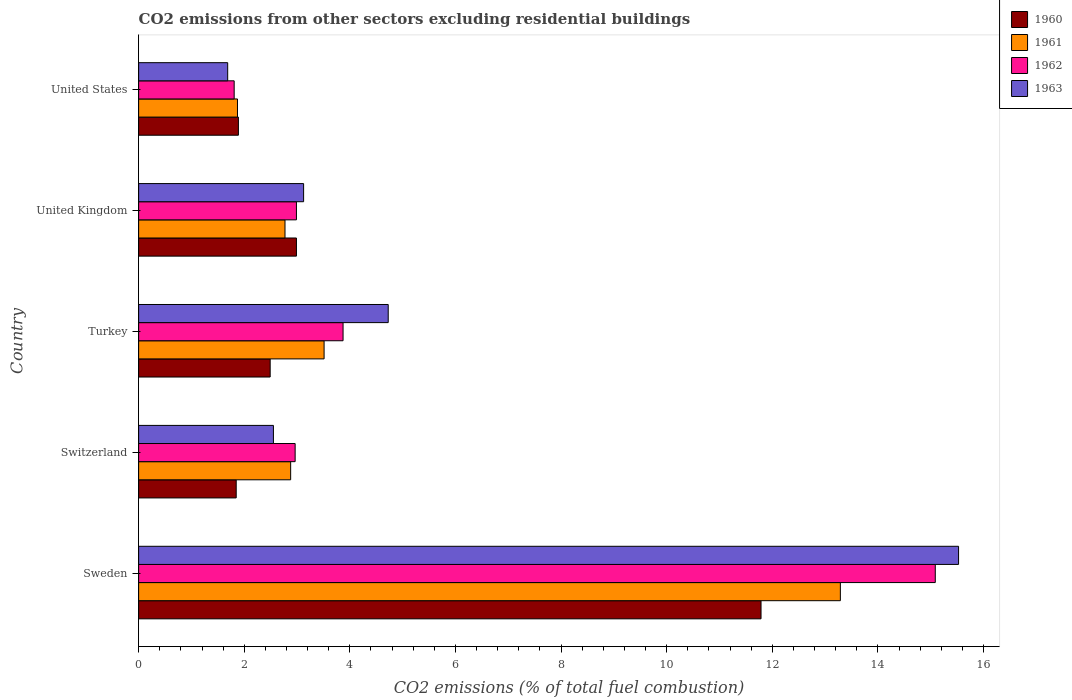Are the number of bars on each tick of the Y-axis equal?
Provide a short and direct response. Yes. What is the label of the 2nd group of bars from the top?
Offer a very short reply. United Kingdom. In how many cases, is the number of bars for a given country not equal to the number of legend labels?
Your response must be concise. 0. What is the total CO2 emitted in 1963 in Turkey?
Give a very brief answer. 4.73. Across all countries, what is the maximum total CO2 emitted in 1963?
Provide a short and direct response. 15.53. Across all countries, what is the minimum total CO2 emitted in 1962?
Keep it short and to the point. 1.81. In which country was the total CO2 emitted in 1961 minimum?
Offer a very short reply. United States. What is the total total CO2 emitted in 1961 in the graph?
Your answer should be compact. 24.32. What is the difference between the total CO2 emitted in 1960 in Turkey and that in United Kingdom?
Offer a very short reply. -0.5. What is the difference between the total CO2 emitted in 1963 in Switzerland and the total CO2 emitted in 1962 in United Kingdom?
Offer a terse response. -0.44. What is the average total CO2 emitted in 1963 per country?
Offer a terse response. 5.52. What is the difference between the total CO2 emitted in 1963 and total CO2 emitted in 1960 in United Kingdom?
Keep it short and to the point. 0.14. In how many countries, is the total CO2 emitted in 1961 greater than 0.8 ?
Your answer should be compact. 5. What is the ratio of the total CO2 emitted in 1962 in Switzerland to that in United States?
Make the answer very short. 1.64. Is the difference between the total CO2 emitted in 1963 in Sweden and Turkey greater than the difference between the total CO2 emitted in 1960 in Sweden and Turkey?
Make the answer very short. Yes. What is the difference between the highest and the second highest total CO2 emitted in 1962?
Provide a succinct answer. 11.21. What is the difference between the highest and the lowest total CO2 emitted in 1963?
Provide a short and direct response. 13.84. Is it the case that in every country, the sum of the total CO2 emitted in 1960 and total CO2 emitted in 1961 is greater than the sum of total CO2 emitted in 1962 and total CO2 emitted in 1963?
Offer a terse response. No. What does the 3rd bar from the bottom in United Kingdom represents?
Offer a terse response. 1962. What is the difference between two consecutive major ticks on the X-axis?
Give a very brief answer. 2. Are the values on the major ticks of X-axis written in scientific E-notation?
Offer a very short reply. No. Does the graph contain any zero values?
Your answer should be very brief. No. Does the graph contain grids?
Give a very brief answer. No. How many legend labels are there?
Your response must be concise. 4. What is the title of the graph?
Your response must be concise. CO2 emissions from other sectors excluding residential buildings. What is the label or title of the X-axis?
Ensure brevity in your answer.  CO2 emissions (% of total fuel combustion). What is the label or title of the Y-axis?
Your answer should be very brief. Country. What is the CO2 emissions (% of total fuel combustion) of 1960 in Sweden?
Offer a very short reply. 11.79. What is the CO2 emissions (% of total fuel combustion) of 1961 in Sweden?
Provide a short and direct response. 13.29. What is the CO2 emissions (% of total fuel combustion) of 1962 in Sweden?
Keep it short and to the point. 15.09. What is the CO2 emissions (% of total fuel combustion) of 1963 in Sweden?
Give a very brief answer. 15.53. What is the CO2 emissions (% of total fuel combustion) in 1960 in Switzerland?
Give a very brief answer. 1.85. What is the CO2 emissions (% of total fuel combustion) of 1961 in Switzerland?
Your answer should be compact. 2.88. What is the CO2 emissions (% of total fuel combustion) in 1962 in Switzerland?
Offer a terse response. 2.96. What is the CO2 emissions (% of total fuel combustion) in 1963 in Switzerland?
Your answer should be compact. 2.55. What is the CO2 emissions (% of total fuel combustion) of 1960 in Turkey?
Provide a short and direct response. 2.49. What is the CO2 emissions (% of total fuel combustion) of 1961 in Turkey?
Provide a short and direct response. 3.51. What is the CO2 emissions (% of total fuel combustion) in 1962 in Turkey?
Ensure brevity in your answer.  3.87. What is the CO2 emissions (% of total fuel combustion) in 1963 in Turkey?
Give a very brief answer. 4.73. What is the CO2 emissions (% of total fuel combustion) of 1960 in United Kingdom?
Keep it short and to the point. 2.99. What is the CO2 emissions (% of total fuel combustion) in 1961 in United Kingdom?
Offer a very short reply. 2.77. What is the CO2 emissions (% of total fuel combustion) of 1962 in United Kingdom?
Offer a terse response. 2.99. What is the CO2 emissions (% of total fuel combustion) in 1963 in United Kingdom?
Ensure brevity in your answer.  3.12. What is the CO2 emissions (% of total fuel combustion) of 1960 in United States?
Provide a succinct answer. 1.89. What is the CO2 emissions (% of total fuel combustion) of 1961 in United States?
Make the answer very short. 1.87. What is the CO2 emissions (% of total fuel combustion) of 1962 in United States?
Offer a terse response. 1.81. What is the CO2 emissions (% of total fuel combustion) of 1963 in United States?
Your answer should be compact. 1.69. Across all countries, what is the maximum CO2 emissions (% of total fuel combustion) in 1960?
Offer a terse response. 11.79. Across all countries, what is the maximum CO2 emissions (% of total fuel combustion) in 1961?
Your answer should be very brief. 13.29. Across all countries, what is the maximum CO2 emissions (% of total fuel combustion) of 1962?
Ensure brevity in your answer.  15.09. Across all countries, what is the maximum CO2 emissions (% of total fuel combustion) in 1963?
Your response must be concise. 15.53. Across all countries, what is the minimum CO2 emissions (% of total fuel combustion) in 1960?
Your answer should be compact. 1.85. Across all countries, what is the minimum CO2 emissions (% of total fuel combustion) in 1961?
Provide a short and direct response. 1.87. Across all countries, what is the minimum CO2 emissions (% of total fuel combustion) of 1962?
Offer a terse response. 1.81. Across all countries, what is the minimum CO2 emissions (% of total fuel combustion) of 1963?
Give a very brief answer. 1.69. What is the total CO2 emissions (% of total fuel combustion) of 1960 in the graph?
Provide a short and direct response. 21. What is the total CO2 emissions (% of total fuel combustion) in 1961 in the graph?
Provide a short and direct response. 24.32. What is the total CO2 emissions (% of total fuel combustion) of 1962 in the graph?
Provide a succinct answer. 26.72. What is the total CO2 emissions (% of total fuel combustion) of 1963 in the graph?
Offer a very short reply. 27.62. What is the difference between the CO2 emissions (% of total fuel combustion) in 1960 in Sweden and that in Switzerland?
Your response must be concise. 9.94. What is the difference between the CO2 emissions (% of total fuel combustion) in 1961 in Sweden and that in Switzerland?
Ensure brevity in your answer.  10.41. What is the difference between the CO2 emissions (% of total fuel combustion) of 1962 in Sweden and that in Switzerland?
Your response must be concise. 12.12. What is the difference between the CO2 emissions (% of total fuel combustion) of 1963 in Sweden and that in Switzerland?
Ensure brevity in your answer.  12.97. What is the difference between the CO2 emissions (% of total fuel combustion) in 1960 in Sweden and that in Turkey?
Provide a short and direct response. 9.3. What is the difference between the CO2 emissions (% of total fuel combustion) of 1961 in Sweden and that in Turkey?
Offer a very short reply. 9.78. What is the difference between the CO2 emissions (% of total fuel combustion) in 1962 in Sweden and that in Turkey?
Give a very brief answer. 11.21. What is the difference between the CO2 emissions (% of total fuel combustion) in 1963 in Sweden and that in Turkey?
Your response must be concise. 10.8. What is the difference between the CO2 emissions (% of total fuel combustion) of 1960 in Sweden and that in United Kingdom?
Offer a very short reply. 8.8. What is the difference between the CO2 emissions (% of total fuel combustion) of 1961 in Sweden and that in United Kingdom?
Provide a short and direct response. 10.52. What is the difference between the CO2 emissions (% of total fuel combustion) of 1962 in Sweden and that in United Kingdom?
Offer a very short reply. 12.1. What is the difference between the CO2 emissions (% of total fuel combustion) in 1963 in Sweden and that in United Kingdom?
Offer a very short reply. 12.4. What is the difference between the CO2 emissions (% of total fuel combustion) of 1960 in Sweden and that in United States?
Your answer should be compact. 9.9. What is the difference between the CO2 emissions (% of total fuel combustion) of 1961 in Sweden and that in United States?
Give a very brief answer. 11.42. What is the difference between the CO2 emissions (% of total fuel combustion) of 1962 in Sweden and that in United States?
Make the answer very short. 13.28. What is the difference between the CO2 emissions (% of total fuel combustion) of 1963 in Sweden and that in United States?
Your response must be concise. 13.84. What is the difference between the CO2 emissions (% of total fuel combustion) in 1960 in Switzerland and that in Turkey?
Your answer should be compact. -0.64. What is the difference between the CO2 emissions (% of total fuel combustion) of 1961 in Switzerland and that in Turkey?
Make the answer very short. -0.63. What is the difference between the CO2 emissions (% of total fuel combustion) of 1962 in Switzerland and that in Turkey?
Your response must be concise. -0.91. What is the difference between the CO2 emissions (% of total fuel combustion) in 1963 in Switzerland and that in Turkey?
Offer a terse response. -2.17. What is the difference between the CO2 emissions (% of total fuel combustion) of 1960 in Switzerland and that in United Kingdom?
Your answer should be compact. -1.14. What is the difference between the CO2 emissions (% of total fuel combustion) of 1961 in Switzerland and that in United Kingdom?
Offer a terse response. 0.11. What is the difference between the CO2 emissions (% of total fuel combustion) in 1962 in Switzerland and that in United Kingdom?
Your answer should be compact. -0.02. What is the difference between the CO2 emissions (% of total fuel combustion) of 1963 in Switzerland and that in United Kingdom?
Make the answer very short. -0.57. What is the difference between the CO2 emissions (% of total fuel combustion) in 1960 in Switzerland and that in United States?
Your response must be concise. -0.04. What is the difference between the CO2 emissions (% of total fuel combustion) in 1962 in Switzerland and that in United States?
Give a very brief answer. 1.15. What is the difference between the CO2 emissions (% of total fuel combustion) in 1963 in Switzerland and that in United States?
Offer a terse response. 0.87. What is the difference between the CO2 emissions (% of total fuel combustion) of 1960 in Turkey and that in United Kingdom?
Ensure brevity in your answer.  -0.5. What is the difference between the CO2 emissions (% of total fuel combustion) in 1961 in Turkey and that in United Kingdom?
Offer a terse response. 0.74. What is the difference between the CO2 emissions (% of total fuel combustion) of 1962 in Turkey and that in United Kingdom?
Your answer should be very brief. 0.88. What is the difference between the CO2 emissions (% of total fuel combustion) of 1963 in Turkey and that in United Kingdom?
Your response must be concise. 1.6. What is the difference between the CO2 emissions (% of total fuel combustion) in 1960 in Turkey and that in United States?
Offer a very short reply. 0.6. What is the difference between the CO2 emissions (% of total fuel combustion) in 1961 in Turkey and that in United States?
Your response must be concise. 1.64. What is the difference between the CO2 emissions (% of total fuel combustion) in 1962 in Turkey and that in United States?
Offer a terse response. 2.06. What is the difference between the CO2 emissions (% of total fuel combustion) in 1963 in Turkey and that in United States?
Offer a terse response. 3.04. What is the difference between the CO2 emissions (% of total fuel combustion) of 1960 in United Kingdom and that in United States?
Offer a very short reply. 1.1. What is the difference between the CO2 emissions (% of total fuel combustion) in 1961 in United Kingdom and that in United States?
Give a very brief answer. 0.9. What is the difference between the CO2 emissions (% of total fuel combustion) of 1962 in United Kingdom and that in United States?
Provide a succinct answer. 1.18. What is the difference between the CO2 emissions (% of total fuel combustion) in 1963 in United Kingdom and that in United States?
Keep it short and to the point. 1.44. What is the difference between the CO2 emissions (% of total fuel combustion) of 1960 in Sweden and the CO2 emissions (% of total fuel combustion) of 1961 in Switzerland?
Give a very brief answer. 8.91. What is the difference between the CO2 emissions (% of total fuel combustion) in 1960 in Sweden and the CO2 emissions (% of total fuel combustion) in 1962 in Switzerland?
Your response must be concise. 8.82. What is the difference between the CO2 emissions (% of total fuel combustion) in 1960 in Sweden and the CO2 emissions (% of total fuel combustion) in 1963 in Switzerland?
Provide a short and direct response. 9.23. What is the difference between the CO2 emissions (% of total fuel combustion) of 1961 in Sweden and the CO2 emissions (% of total fuel combustion) of 1962 in Switzerland?
Give a very brief answer. 10.32. What is the difference between the CO2 emissions (% of total fuel combustion) of 1961 in Sweden and the CO2 emissions (% of total fuel combustion) of 1963 in Switzerland?
Provide a short and direct response. 10.74. What is the difference between the CO2 emissions (% of total fuel combustion) in 1962 in Sweden and the CO2 emissions (% of total fuel combustion) in 1963 in Switzerland?
Ensure brevity in your answer.  12.53. What is the difference between the CO2 emissions (% of total fuel combustion) of 1960 in Sweden and the CO2 emissions (% of total fuel combustion) of 1961 in Turkey?
Offer a very short reply. 8.27. What is the difference between the CO2 emissions (% of total fuel combustion) of 1960 in Sweden and the CO2 emissions (% of total fuel combustion) of 1962 in Turkey?
Your answer should be very brief. 7.91. What is the difference between the CO2 emissions (% of total fuel combustion) in 1960 in Sweden and the CO2 emissions (% of total fuel combustion) in 1963 in Turkey?
Offer a very short reply. 7.06. What is the difference between the CO2 emissions (% of total fuel combustion) of 1961 in Sweden and the CO2 emissions (% of total fuel combustion) of 1962 in Turkey?
Offer a terse response. 9.42. What is the difference between the CO2 emissions (% of total fuel combustion) of 1961 in Sweden and the CO2 emissions (% of total fuel combustion) of 1963 in Turkey?
Keep it short and to the point. 8.56. What is the difference between the CO2 emissions (% of total fuel combustion) in 1962 in Sweden and the CO2 emissions (% of total fuel combustion) in 1963 in Turkey?
Give a very brief answer. 10.36. What is the difference between the CO2 emissions (% of total fuel combustion) in 1960 in Sweden and the CO2 emissions (% of total fuel combustion) in 1961 in United Kingdom?
Ensure brevity in your answer.  9.01. What is the difference between the CO2 emissions (% of total fuel combustion) of 1960 in Sweden and the CO2 emissions (% of total fuel combustion) of 1962 in United Kingdom?
Ensure brevity in your answer.  8.8. What is the difference between the CO2 emissions (% of total fuel combustion) of 1960 in Sweden and the CO2 emissions (% of total fuel combustion) of 1963 in United Kingdom?
Give a very brief answer. 8.66. What is the difference between the CO2 emissions (% of total fuel combustion) in 1961 in Sweden and the CO2 emissions (% of total fuel combustion) in 1962 in United Kingdom?
Your answer should be compact. 10.3. What is the difference between the CO2 emissions (% of total fuel combustion) in 1961 in Sweden and the CO2 emissions (% of total fuel combustion) in 1963 in United Kingdom?
Your answer should be compact. 10.16. What is the difference between the CO2 emissions (% of total fuel combustion) in 1962 in Sweden and the CO2 emissions (% of total fuel combustion) in 1963 in United Kingdom?
Offer a terse response. 11.96. What is the difference between the CO2 emissions (% of total fuel combustion) of 1960 in Sweden and the CO2 emissions (% of total fuel combustion) of 1961 in United States?
Offer a very short reply. 9.91. What is the difference between the CO2 emissions (% of total fuel combustion) in 1960 in Sweden and the CO2 emissions (% of total fuel combustion) in 1962 in United States?
Keep it short and to the point. 9.98. What is the difference between the CO2 emissions (% of total fuel combustion) in 1960 in Sweden and the CO2 emissions (% of total fuel combustion) in 1963 in United States?
Your answer should be very brief. 10.1. What is the difference between the CO2 emissions (% of total fuel combustion) in 1961 in Sweden and the CO2 emissions (% of total fuel combustion) in 1962 in United States?
Provide a succinct answer. 11.48. What is the difference between the CO2 emissions (% of total fuel combustion) in 1961 in Sweden and the CO2 emissions (% of total fuel combustion) in 1963 in United States?
Make the answer very short. 11.6. What is the difference between the CO2 emissions (% of total fuel combustion) in 1962 in Sweden and the CO2 emissions (% of total fuel combustion) in 1963 in United States?
Keep it short and to the point. 13.4. What is the difference between the CO2 emissions (% of total fuel combustion) of 1960 in Switzerland and the CO2 emissions (% of total fuel combustion) of 1961 in Turkey?
Your response must be concise. -1.66. What is the difference between the CO2 emissions (% of total fuel combustion) in 1960 in Switzerland and the CO2 emissions (% of total fuel combustion) in 1962 in Turkey?
Provide a succinct answer. -2.02. What is the difference between the CO2 emissions (% of total fuel combustion) in 1960 in Switzerland and the CO2 emissions (% of total fuel combustion) in 1963 in Turkey?
Your answer should be very brief. -2.88. What is the difference between the CO2 emissions (% of total fuel combustion) of 1961 in Switzerland and the CO2 emissions (% of total fuel combustion) of 1962 in Turkey?
Provide a succinct answer. -0.99. What is the difference between the CO2 emissions (% of total fuel combustion) in 1961 in Switzerland and the CO2 emissions (% of total fuel combustion) in 1963 in Turkey?
Give a very brief answer. -1.85. What is the difference between the CO2 emissions (% of total fuel combustion) in 1962 in Switzerland and the CO2 emissions (% of total fuel combustion) in 1963 in Turkey?
Make the answer very short. -1.76. What is the difference between the CO2 emissions (% of total fuel combustion) of 1960 in Switzerland and the CO2 emissions (% of total fuel combustion) of 1961 in United Kingdom?
Provide a succinct answer. -0.92. What is the difference between the CO2 emissions (% of total fuel combustion) in 1960 in Switzerland and the CO2 emissions (% of total fuel combustion) in 1962 in United Kingdom?
Your response must be concise. -1.14. What is the difference between the CO2 emissions (% of total fuel combustion) in 1960 in Switzerland and the CO2 emissions (% of total fuel combustion) in 1963 in United Kingdom?
Offer a terse response. -1.28. What is the difference between the CO2 emissions (% of total fuel combustion) in 1961 in Switzerland and the CO2 emissions (% of total fuel combustion) in 1962 in United Kingdom?
Your response must be concise. -0.11. What is the difference between the CO2 emissions (% of total fuel combustion) of 1961 in Switzerland and the CO2 emissions (% of total fuel combustion) of 1963 in United Kingdom?
Offer a terse response. -0.25. What is the difference between the CO2 emissions (% of total fuel combustion) in 1962 in Switzerland and the CO2 emissions (% of total fuel combustion) in 1963 in United Kingdom?
Provide a short and direct response. -0.16. What is the difference between the CO2 emissions (% of total fuel combustion) of 1960 in Switzerland and the CO2 emissions (% of total fuel combustion) of 1961 in United States?
Give a very brief answer. -0.02. What is the difference between the CO2 emissions (% of total fuel combustion) in 1960 in Switzerland and the CO2 emissions (% of total fuel combustion) in 1962 in United States?
Keep it short and to the point. 0.04. What is the difference between the CO2 emissions (% of total fuel combustion) of 1960 in Switzerland and the CO2 emissions (% of total fuel combustion) of 1963 in United States?
Provide a succinct answer. 0.16. What is the difference between the CO2 emissions (% of total fuel combustion) in 1961 in Switzerland and the CO2 emissions (% of total fuel combustion) in 1962 in United States?
Provide a succinct answer. 1.07. What is the difference between the CO2 emissions (% of total fuel combustion) in 1961 in Switzerland and the CO2 emissions (% of total fuel combustion) in 1963 in United States?
Offer a terse response. 1.19. What is the difference between the CO2 emissions (% of total fuel combustion) of 1962 in Switzerland and the CO2 emissions (% of total fuel combustion) of 1963 in United States?
Your response must be concise. 1.28. What is the difference between the CO2 emissions (% of total fuel combustion) of 1960 in Turkey and the CO2 emissions (% of total fuel combustion) of 1961 in United Kingdom?
Provide a short and direct response. -0.28. What is the difference between the CO2 emissions (% of total fuel combustion) in 1960 in Turkey and the CO2 emissions (% of total fuel combustion) in 1962 in United Kingdom?
Keep it short and to the point. -0.5. What is the difference between the CO2 emissions (% of total fuel combustion) of 1960 in Turkey and the CO2 emissions (% of total fuel combustion) of 1963 in United Kingdom?
Give a very brief answer. -0.63. What is the difference between the CO2 emissions (% of total fuel combustion) of 1961 in Turkey and the CO2 emissions (% of total fuel combustion) of 1962 in United Kingdom?
Make the answer very short. 0.52. What is the difference between the CO2 emissions (% of total fuel combustion) of 1961 in Turkey and the CO2 emissions (% of total fuel combustion) of 1963 in United Kingdom?
Offer a terse response. 0.39. What is the difference between the CO2 emissions (% of total fuel combustion) of 1962 in Turkey and the CO2 emissions (% of total fuel combustion) of 1963 in United Kingdom?
Your response must be concise. 0.75. What is the difference between the CO2 emissions (% of total fuel combustion) of 1960 in Turkey and the CO2 emissions (% of total fuel combustion) of 1961 in United States?
Provide a succinct answer. 0.62. What is the difference between the CO2 emissions (% of total fuel combustion) in 1960 in Turkey and the CO2 emissions (% of total fuel combustion) in 1962 in United States?
Keep it short and to the point. 0.68. What is the difference between the CO2 emissions (% of total fuel combustion) in 1960 in Turkey and the CO2 emissions (% of total fuel combustion) in 1963 in United States?
Provide a succinct answer. 0.8. What is the difference between the CO2 emissions (% of total fuel combustion) in 1961 in Turkey and the CO2 emissions (% of total fuel combustion) in 1962 in United States?
Your response must be concise. 1.7. What is the difference between the CO2 emissions (% of total fuel combustion) of 1961 in Turkey and the CO2 emissions (% of total fuel combustion) of 1963 in United States?
Make the answer very short. 1.83. What is the difference between the CO2 emissions (% of total fuel combustion) of 1962 in Turkey and the CO2 emissions (% of total fuel combustion) of 1963 in United States?
Provide a succinct answer. 2.18. What is the difference between the CO2 emissions (% of total fuel combustion) of 1960 in United Kingdom and the CO2 emissions (% of total fuel combustion) of 1961 in United States?
Your answer should be compact. 1.12. What is the difference between the CO2 emissions (% of total fuel combustion) of 1960 in United Kingdom and the CO2 emissions (% of total fuel combustion) of 1962 in United States?
Offer a terse response. 1.18. What is the difference between the CO2 emissions (% of total fuel combustion) in 1960 in United Kingdom and the CO2 emissions (% of total fuel combustion) in 1963 in United States?
Your answer should be very brief. 1.3. What is the difference between the CO2 emissions (% of total fuel combustion) of 1961 in United Kingdom and the CO2 emissions (% of total fuel combustion) of 1962 in United States?
Give a very brief answer. 0.96. What is the difference between the CO2 emissions (% of total fuel combustion) of 1961 in United Kingdom and the CO2 emissions (% of total fuel combustion) of 1963 in United States?
Your response must be concise. 1.09. What is the difference between the CO2 emissions (% of total fuel combustion) in 1962 in United Kingdom and the CO2 emissions (% of total fuel combustion) in 1963 in United States?
Keep it short and to the point. 1.3. What is the average CO2 emissions (% of total fuel combustion) in 1960 per country?
Your answer should be very brief. 4.2. What is the average CO2 emissions (% of total fuel combustion) of 1961 per country?
Your answer should be very brief. 4.86. What is the average CO2 emissions (% of total fuel combustion) in 1962 per country?
Make the answer very short. 5.34. What is the average CO2 emissions (% of total fuel combustion) of 1963 per country?
Keep it short and to the point. 5.52. What is the difference between the CO2 emissions (% of total fuel combustion) in 1960 and CO2 emissions (% of total fuel combustion) in 1961 in Sweden?
Offer a terse response. -1.5. What is the difference between the CO2 emissions (% of total fuel combustion) in 1960 and CO2 emissions (% of total fuel combustion) in 1962 in Sweden?
Provide a succinct answer. -3.3. What is the difference between the CO2 emissions (% of total fuel combustion) in 1960 and CO2 emissions (% of total fuel combustion) in 1963 in Sweden?
Your answer should be very brief. -3.74. What is the difference between the CO2 emissions (% of total fuel combustion) of 1961 and CO2 emissions (% of total fuel combustion) of 1962 in Sweden?
Ensure brevity in your answer.  -1.8. What is the difference between the CO2 emissions (% of total fuel combustion) of 1961 and CO2 emissions (% of total fuel combustion) of 1963 in Sweden?
Provide a succinct answer. -2.24. What is the difference between the CO2 emissions (% of total fuel combustion) in 1962 and CO2 emissions (% of total fuel combustion) in 1963 in Sweden?
Offer a terse response. -0.44. What is the difference between the CO2 emissions (% of total fuel combustion) in 1960 and CO2 emissions (% of total fuel combustion) in 1961 in Switzerland?
Offer a terse response. -1.03. What is the difference between the CO2 emissions (% of total fuel combustion) in 1960 and CO2 emissions (% of total fuel combustion) in 1962 in Switzerland?
Offer a very short reply. -1.12. What is the difference between the CO2 emissions (% of total fuel combustion) in 1960 and CO2 emissions (% of total fuel combustion) in 1963 in Switzerland?
Your response must be concise. -0.7. What is the difference between the CO2 emissions (% of total fuel combustion) in 1961 and CO2 emissions (% of total fuel combustion) in 1962 in Switzerland?
Offer a terse response. -0.08. What is the difference between the CO2 emissions (% of total fuel combustion) in 1961 and CO2 emissions (% of total fuel combustion) in 1963 in Switzerland?
Offer a very short reply. 0.33. What is the difference between the CO2 emissions (% of total fuel combustion) in 1962 and CO2 emissions (% of total fuel combustion) in 1963 in Switzerland?
Keep it short and to the point. 0.41. What is the difference between the CO2 emissions (% of total fuel combustion) of 1960 and CO2 emissions (% of total fuel combustion) of 1961 in Turkey?
Your answer should be compact. -1.02. What is the difference between the CO2 emissions (% of total fuel combustion) in 1960 and CO2 emissions (% of total fuel combustion) in 1962 in Turkey?
Give a very brief answer. -1.38. What is the difference between the CO2 emissions (% of total fuel combustion) of 1960 and CO2 emissions (% of total fuel combustion) of 1963 in Turkey?
Give a very brief answer. -2.24. What is the difference between the CO2 emissions (% of total fuel combustion) of 1961 and CO2 emissions (% of total fuel combustion) of 1962 in Turkey?
Your response must be concise. -0.36. What is the difference between the CO2 emissions (% of total fuel combustion) of 1961 and CO2 emissions (% of total fuel combustion) of 1963 in Turkey?
Give a very brief answer. -1.21. What is the difference between the CO2 emissions (% of total fuel combustion) of 1962 and CO2 emissions (% of total fuel combustion) of 1963 in Turkey?
Keep it short and to the point. -0.85. What is the difference between the CO2 emissions (% of total fuel combustion) of 1960 and CO2 emissions (% of total fuel combustion) of 1961 in United Kingdom?
Give a very brief answer. 0.22. What is the difference between the CO2 emissions (% of total fuel combustion) of 1960 and CO2 emissions (% of total fuel combustion) of 1962 in United Kingdom?
Give a very brief answer. -0. What is the difference between the CO2 emissions (% of total fuel combustion) in 1960 and CO2 emissions (% of total fuel combustion) in 1963 in United Kingdom?
Make the answer very short. -0.14. What is the difference between the CO2 emissions (% of total fuel combustion) of 1961 and CO2 emissions (% of total fuel combustion) of 1962 in United Kingdom?
Offer a terse response. -0.22. What is the difference between the CO2 emissions (% of total fuel combustion) of 1961 and CO2 emissions (% of total fuel combustion) of 1963 in United Kingdom?
Offer a very short reply. -0.35. What is the difference between the CO2 emissions (% of total fuel combustion) in 1962 and CO2 emissions (% of total fuel combustion) in 1963 in United Kingdom?
Ensure brevity in your answer.  -0.14. What is the difference between the CO2 emissions (% of total fuel combustion) in 1960 and CO2 emissions (% of total fuel combustion) in 1961 in United States?
Provide a succinct answer. 0.02. What is the difference between the CO2 emissions (% of total fuel combustion) of 1960 and CO2 emissions (% of total fuel combustion) of 1962 in United States?
Your answer should be very brief. 0.08. What is the difference between the CO2 emissions (% of total fuel combustion) of 1960 and CO2 emissions (% of total fuel combustion) of 1963 in United States?
Your answer should be compact. 0.2. What is the difference between the CO2 emissions (% of total fuel combustion) in 1961 and CO2 emissions (% of total fuel combustion) in 1962 in United States?
Your answer should be very brief. 0.06. What is the difference between the CO2 emissions (% of total fuel combustion) of 1961 and CO2 emissions (% of total fuel combustion) of 1963 in United States?
Your answer should be very brief. 0.19. What is the difference between the CO2 emissions (% of total fuel combustion) in 1962 and CO2 emissions (% of total fuel combustion) in 1963 in United States?
Give a very brief answer. 0.12. What is the ratio of the CO2 emissions (% of total fuel combustion) in 1960 in Sweden to that in Switzerland?
Your answer should be compact. 6.38. What is the ratio of the CO2 emissions (% of total fuel combustion) of 1961 in Sweden to that in Switzerland?
Provide a succinct answer. 4.62. What is the ratio of the CO2 emissions (% of total fuel combustion) of 1962 in Sweden to that in Switzerland?
Your answer should be very brief. 5.09. What is the ratio of the CO2 emissions (% of total fuel combustion) in 1963 in Sweden to that in Switzerland?
Your answer should be very brief. 6.08. What is the ratio of the CO2 emissions (% of total fuel combustion) of 1960 in Sweden to that in Turkey?
Provide a succinct answer. 4.73. What is the ratio of the CO2 emissions (% of total fuel combustion) in 1961 in Sweden to that in Turkey?
Your answer should be very brief. 3.78. What is the ratio of the CO2 emissions (% of total fuel combustion) of 1962 in Sweden to that in Turkey?
Give a very brief answer. 3.9. What is the ratio of the CO2 emissions (% of total fuel combustion) in 1963 in Sweden to that in Turkey?
Your answer should be compact. 3.29. What is the ratio of the CO2 emissions (% of total fuel combustion) in 1960 in Sweden to that in United Kingdom?
Provide a succinct answer. 3.94. What is the ratio of the CO2 emissions (% of total fuel combustion) in 1961 in Sweden to that in United Kingdom?
Offer a very short reply. 4.79. What is the ratio of the CO2 emissions (% of total fuel combustion) in 1962 in Sweden to that in United Kingdom?
Your answer should be very brief. 5.05. What is the ratio of the CO2 emissions (% of total fuel combustion) of 1963 in Sweden to that in United Kingdom?
Provide a succinct answer. 4.97. What is the ratio of the CO2 emissions (% of total fuel combustion) of 1960 in Sweden to that in United States?
Your answer should be very brief. 6.24. What is the ratio of the CO2 emissions (% of total fuel combustion) in 1961 in Sweden to that in United States?
Offer a very short reply. 7.1. What is the ratio of the CO2 emissions (% of total fuel combustion) of 1962 in Sweden to that in United States?
Keep it short and to the point. 8.34. What is the ratio of the CO2 emissions (% of total fuel combustion) of 1963 in Sweden to that in United States?
Your answer should be compact. 9.21. What is the ratio of the CO2 emissions (% of total fuel combustion) of 1960 in Switzerland to that in Turkey?
Offer a terse response. 0.74. What is the ratio of the CO2 emissions (% of total fuel combustion) in 1961 in Switzerland to that in Turkey?
Offer a very short reply. 0.82. What is the ratio of the CO2 emissions (% of total fuel combustion) in 1962 in Switzerland to that in Turkey?
Give a very brief answer. 0.77. What is the ratio of the CO2 emissions (% of total fuel combustion) of 1963 in Switzerland to that in Turkey?
Offer a terse response. 0.54. What is the ratio of the CO2 emissions (% of total fuel combustion) in 1960 in Switzerland to that in United Kingdom?
Keep it short and to the point. 0.62. What is the ratio of the CO2 emissions (% of total fuel combustion) of 1961 in Switzerland to that in United Kingdom?
Offer a very short reply. 1.04. What is the ratio of the CO2 emissions (% of total fuel combustion) in 1963 in Switzerland to that in United Kingdom?
Your response must be concise. 0.82. What is the ratio of the CO2 emissions (% of total fuel combustion) of 1960 in Switzerland to that in United States?
Your answer should be very brief. 0.98. What is the ratio of the CO2 emissions (% of total fuel combustion) in 1961 in Switzerland to that in United States?
Give a very brief answer. 1.54. What is the ratio of the CO2 emissions (% of total fuel combustion) of 1962 in Switzerland to that in United States?
Your answer should be compact. 1.64. What is the ratio of the CO2 emissions (% of total fuel combustion) in 1963 in Switzerland to that in United States?
Give a very brief answer. 1.51. What is the ratio of the CO2 emissions (% of total fuel combustion) of 1960 in Turkey to that in United Kingdom?
Your answer should be compact. 0.83. What is the ratio of the CO2 emissions (% of total fuel combustion) of 1961 in Turkey to that in United Kingdom?
Offer a terse response. 1.27. What is the ratio of the CO2 emissions (% of total fuel combustion) of 1962 in Turkey to that in United Kingdom?
Provide a short and direct response. 1.3. What is the ratio of the CO2 emissions (% of total fuel combustion) of 1963 in Turkey to that in United Kingdom?
Offer a terse response. 1.51. What is the ratio of the CO2 emissions (% of total fuel combustion) in 1960 in Turkey to that in United States?
Make the answer very short. 1.32. What is the ratio of the CO2 emissions (% of total fuel combustion) of 1961 in Turkey to that in United States?
Give a very brief answer. 1.88. What is the ratio of the CO2 emissions (% of total fuel combustion) of 1962 in Turkey to that in United States?
Offer a terse response. 2.14. What is the ratio of the CO2 emissions (% of total fuel combustion) of 1963 in Turkey to that in United States?
Provide a succinct answer. 2.8. What is the ratio of the CO2 emissions (% of total fuel combustion) of 1960 in United Kingdom to that in United States?
Ensure brevity in your answer.  1.58. What is the ratio of the CO2 emissions (% of total fuel combustion) of 1961 in United Kingdom to that in United States?
Your answer should be compact. 1.48. What is the ratio of the CO2 emissions (% of total fuel combustion) of 1962 in United Kingdom to that in United States?
Your answer should be compact. 1.65. What is the ratio of the CO2 emissions (% of total fuel combustion) of 1963 in United Kingdom to that in United States?
Ensure brevity in your answer.  1.85. What is the difference between the highest and the second highest CO2 emissions (% of total fuel combustion) in 1960?
Ensure brevity in your answer.  8.8. What is the difference between the highest and the second highest CO2 emissions (% of total fuel combustion) in 1961?
Keep it short and to the point. 9.78. What is the difference between the highest and the second highest CO2 emissions (% of total fuel combustion) of 1962?
Your answer should be compact. 11.21. What is the difference between the highest and the second highest CO2 emissions (% of total fuel combustion) in 1963?
Offer a very short reply. 10.8. What is the difference between the highest and the lowest CO2 emissions (% of total fuel combustion) of 1960?
Give a very brief answer. 9.94. What is the difference between the highest and the lowest CO2 emissions (% of total fuel combustion) of 1961?
Give a very brief answer. 11.42. What is the difference between the highest and the lowest CO2 emissions (% of total fuel combustion) of 1962?
Offer a terse response. 13.28. What is the difference between the highest and the lowest CO2 emissions (% of total fuel combustion) in 1963?
Provide a short and direct response. 13.84. 